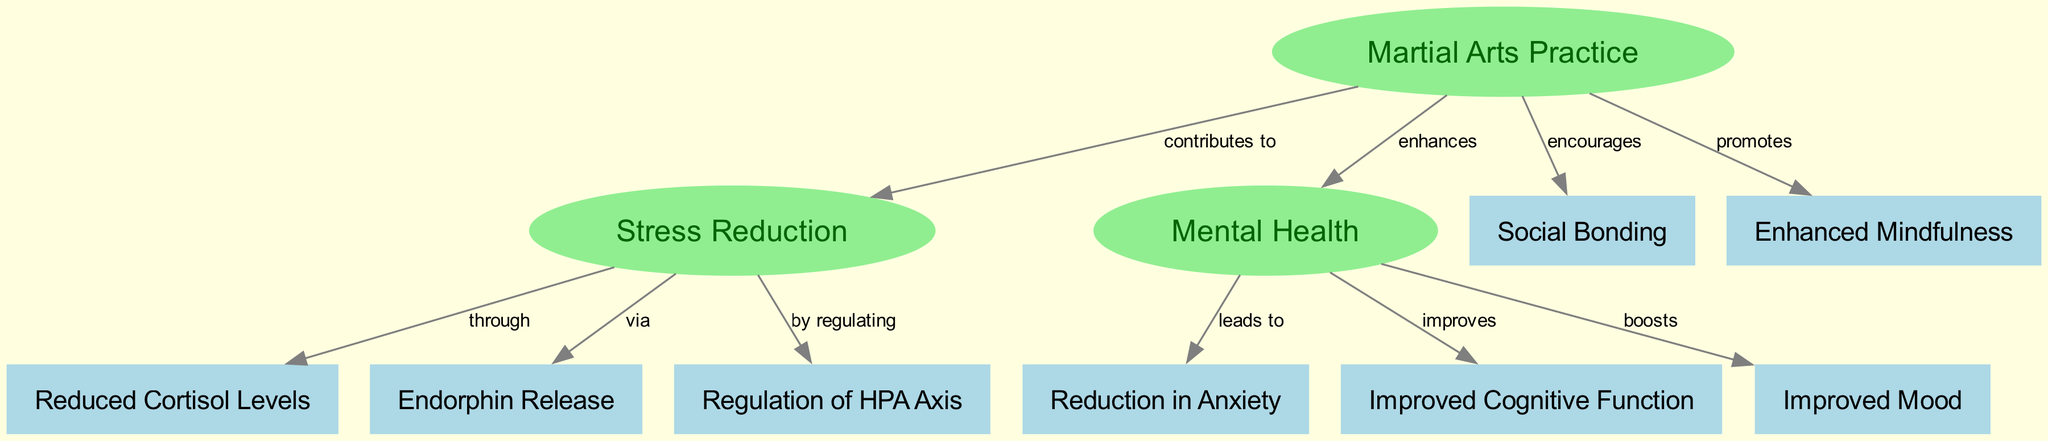What are the three main effects of martial arts practice as shown in the diagram? The diagram highlights three main effects: stress reduction, enhancement of mental health, and encouragement of social bonding. Each effect is represented as a key node.
Answer: Stress Reduction, Mental Health, Social Bonding How many nodes are there in the diagram? The diagram contains a total of 11 nodes, including the main concepts and their effects, as listed in the data provided.
Answer: 11 What does martial arts practice contribute to according to the diagram? The edges indicate that martial arts practice contributes to stress reduction and enhances mental health, establishing relationships with these concepts.
Answer: Stress Reduction What is the relationship between stress reduction and cortisol levels? The diagram shows that stress reduction occurs through the reduction of cortisol levels, establishing a direct connection between the two nodes based on the edge label.
Answer: through Which effects does mental health improve? The diagram indicates that an improvement in mental health leads to a reduction in anxiety, improved cognitive function, and an improved mood. The relationships are represented through directed edges connecting these nodes.
Answer: Reduction in Anxiety, Improved Cognitive Function, Improved Mood What promotes mindfulness in the context of martial arts practice? According to the diagram, mindfulness is promoted directly by martial arts practice, as indicated by the corresponding edge from 'Martial Arts Practice' to 'Mindfulness'.
Answer: Martial Arts Practice Which neurobiological effect of martial arts practice is linked to anxiety reduction? The diagram illustrates that anxiety reduction is directly linked to improved mental health, forming a causal relationship represented by an edge from mental health to anxiety reduction.
Answer: Improved Mental Health 